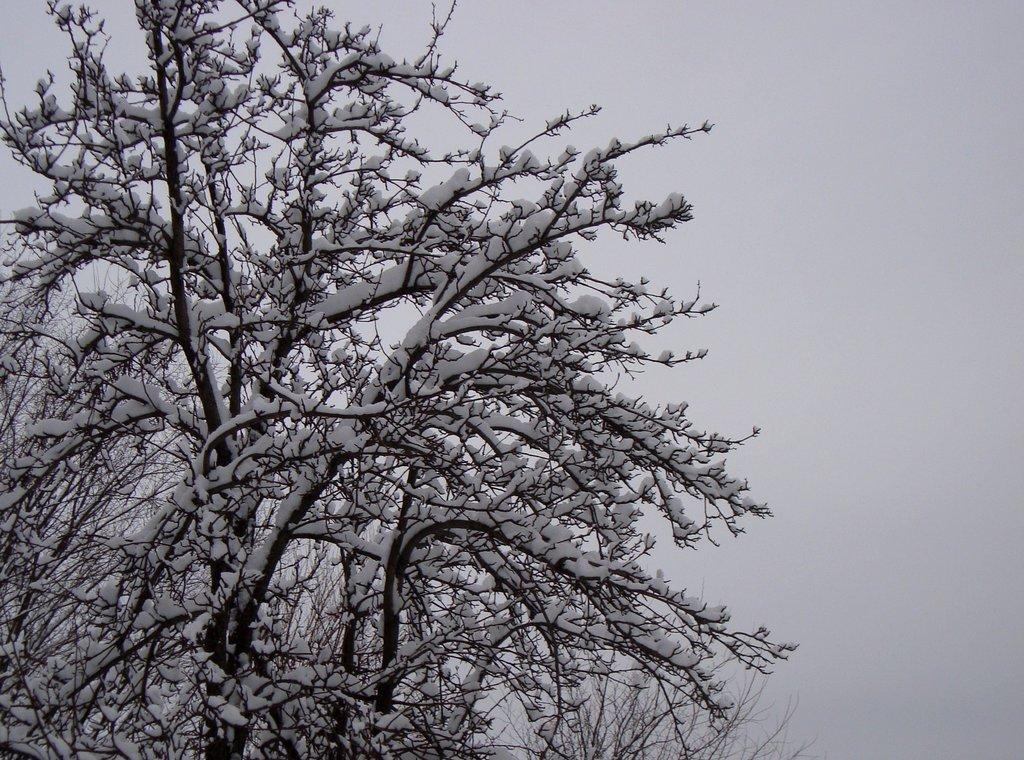What type of vegetation is present in the image? There are trees in the image. What is covering the trees in the image? There is snow on the trees. What is visible at the top of the image? The sky is visible at the top of the image. Can you see the ocean in the image? No, there is no ocean present in the image. Is there an office building visible in the image? No, there is no office building present in the image. 